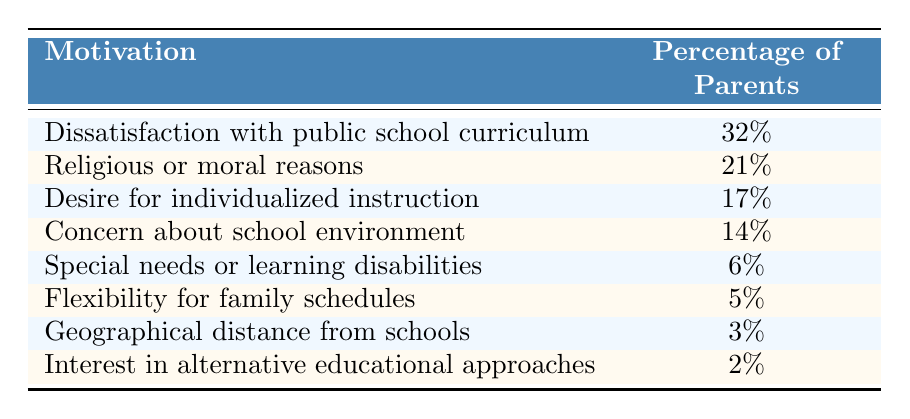What is the most common motivation for choosing homeschooling? The table shows that the most common motivation is "Dissatisfaction with public school curriculum," which has a percentage of 32%.
Answer: 32% What percentage of parents chose homeschooling for geographical distance from schools? According to the table, 3% of parents cited "Geographical distance from schools" as their motivation for homeschooling.
Answer: 3% How many motivations have more than 10% of parents choosing homeschooling? The motivations with more than 10% are "Dissatisfaction with public school curriculum" (32%), "Religious or moral reasons" (21%), "Desire for individualized instruction" (17%), and "Concern about school environment" (14%). That totals to 4 motivations.
Answer: 4 What is the total percentage of parents motivated by concerns about public school curriculum and environment combined? By summing the percentages for "Dissatisfaction with public school curriculum" (32%) and "Concern about school environment" (14%), the total is 32% + 14% = 46%.
Answer: 46% Is "Interest in alternative educational approaches" a common motivation for homeschooling? The table shows that only 2% of parents selected "Interest in alternative educational approaches," indicating it's not a common motivation.
Answer: No 